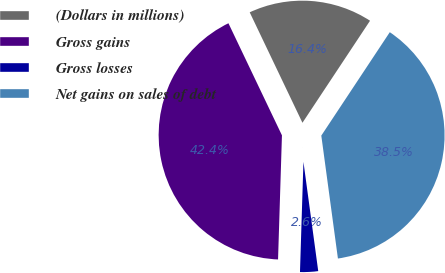<chart> <loc_0><loc_0><loc_500><loc_500><pie_chart><fcel>(Dollars in millions)<fcel>Gross gains<fcel>Gross losses<fcel>Net gains on sales of debt<nl><fcel>16.4%<fcel>42.41%<fcel>2.64%<fcel>38.55%<nl></chart> 